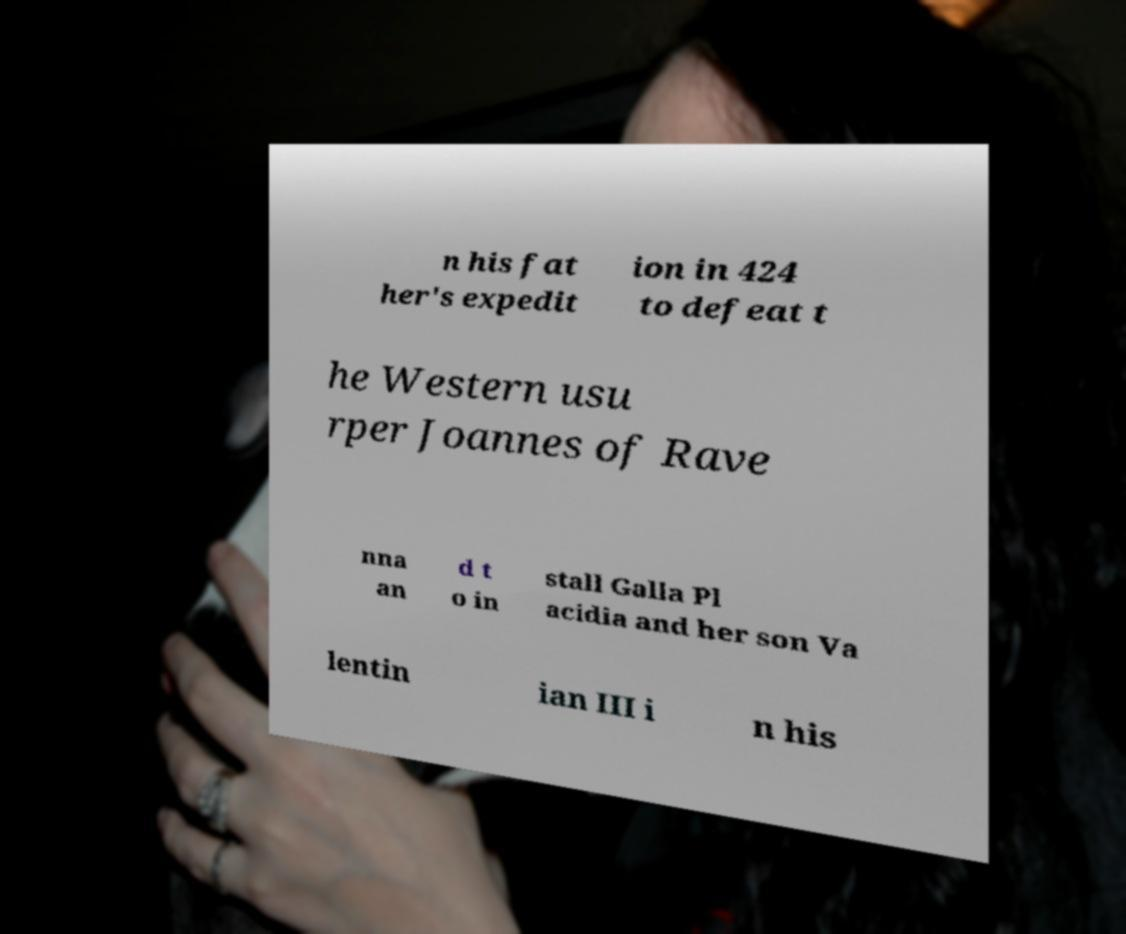Could you assist in decoding the text presented in this image and type it out clearly? n his fat her's expedit ion in 424 to defeat t he Western usu rper Joannes of Rave nna an d t o in stall Galla Pl acidia and her son Va lentin ian III i n his 